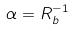<formula> <loc_0><loc_0><loc_500><loc_500>\alpha = R _ { b } ^ { - 1 }</formula> 